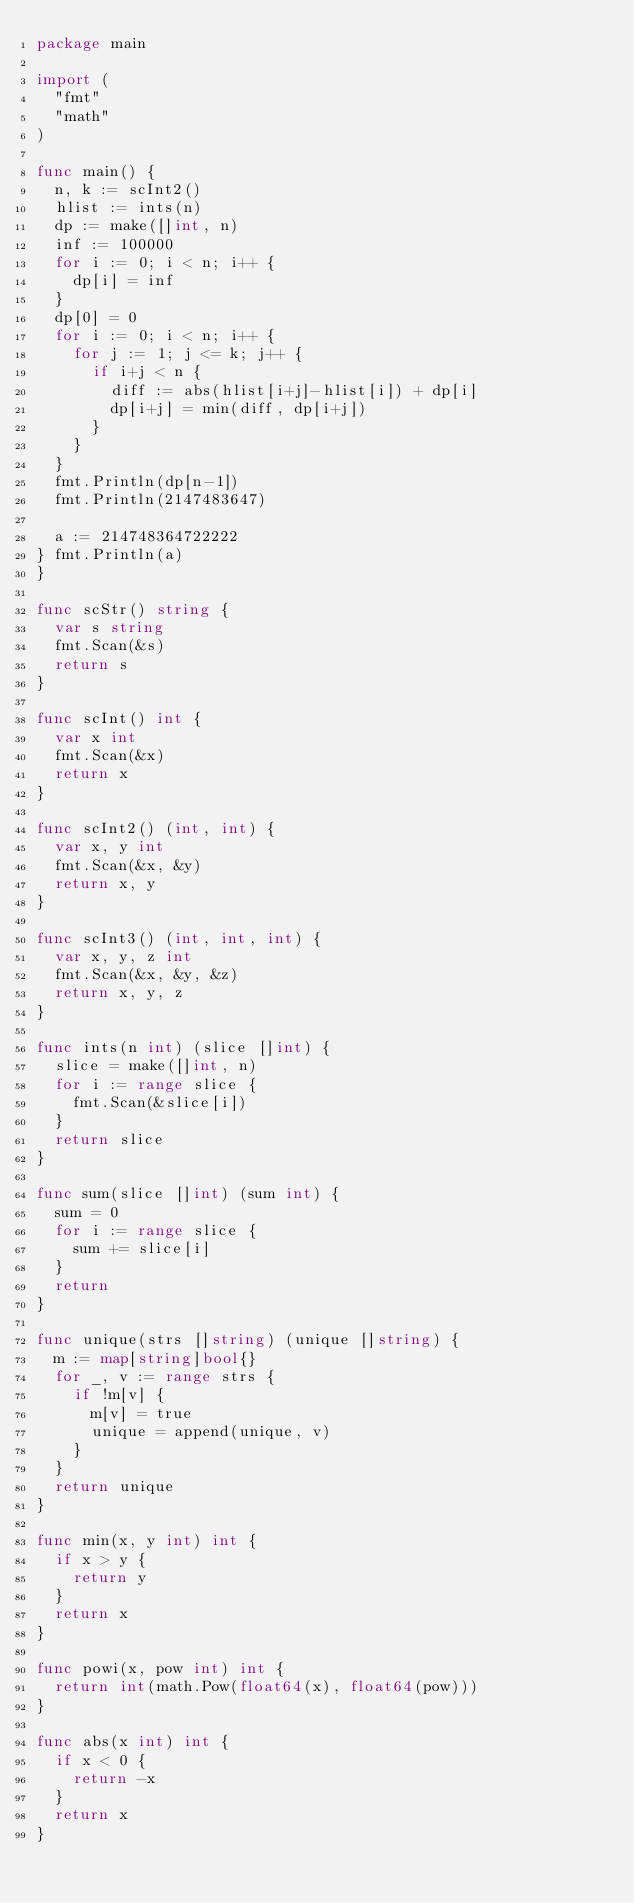Convert code to text. <code><loc_0><loc_0><loc_500><loc_500><_Go_>package main

import (
	"fmt"
	"math"
)

func main() {
	n, k := scInt2()
	hlist := ints(n)
	dp := make([]int, n)
	inf := 100000
	for i := 0; i < n; i++ {
		dp[i] = inf
	}
	dp[0] = 0
	for i := 0; i < n; i++ {
		for j := 1; j <= k; j++ {
			if i+j < n {
				diff := abs(hlist[i+j]-hlist[i]) + dp[i]
				dp[i+j] = min(diff, dp[i+j])
			}
		}
	}
	fmt.Println(dp[n-1])
	fmt.Println(2147483647)

	a := 214748364722222
}	fmt.Println(a)
}

func scStr() string {
	var s string
	fmt.Scan(&s)
	return s
}

func scInt() int {
	var x int
	fmt.Scan(&x)
	return x
}

func scInt2() (int, int) {
	var x, y int
	fmt.Scan(&x, &y)
	return x, y
}

func scInt3() (int, int, int) {
	var x, y, z int
	fmt.Scan(&x, &y, &z)
	return x, y, z
}

func ints(n int) (slice []int) {
	slice = make([]int, n)
	for i := range slice {
		fmt.Scan(&slice[i])
	}
	return slice
}

func sum(slice []int) (sum int) {
	sum = 0
	for i := range slice {
		sum += slice[i]
	}
	return
}

func unique(strs []string) (unique []string) {
	m := map[string]bool{}
	for _, v := range strs {
		if !m[v] {
			m[v] = true
			unique = append(unique, v)
		}
	}
	return unique
}

func min(x, y int) int {
	if x > y {
		return y
	}
	return x
}

func powi(x, pow int) int {
	return int(math.Pow(float64(x), float64(pow)))
}

func abs(x int) int {
	if x < 0 {
		return -x
	}
	return x
}
</code> 